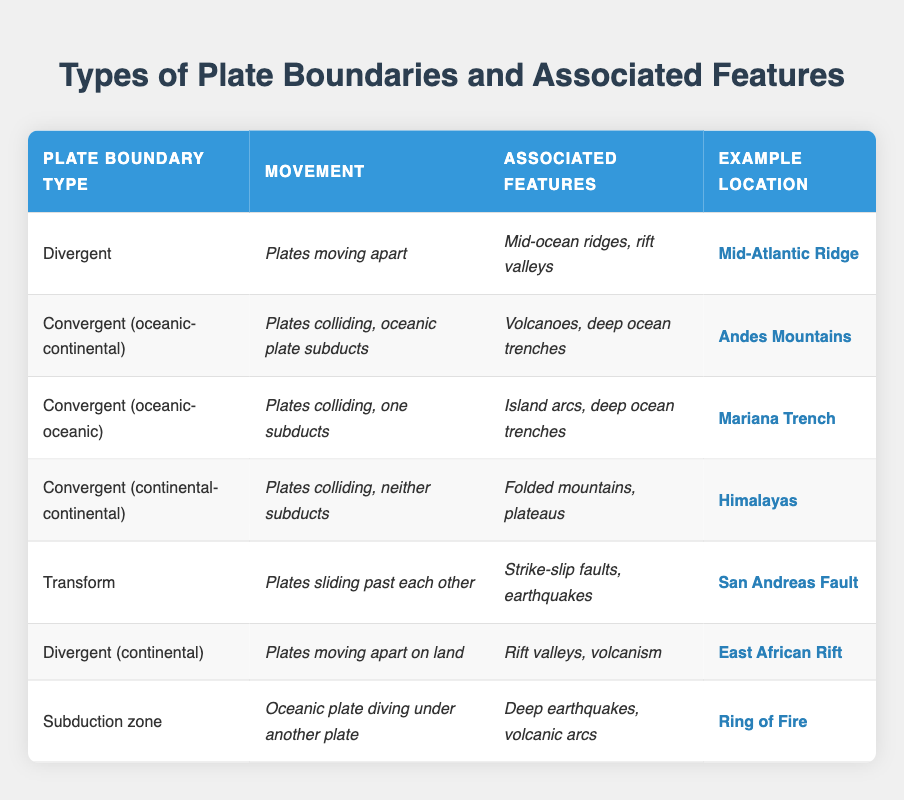What is the movement described for convergent (oceanic-continental) boundaries? According to the table, convergent (oceanic-continental) boundaries are characterized by plates colliding, and the oceanic plate subducts.
Answer: Plates colliding, oceanic plate subducts Which example location is associated with transform boundaries? Looking at the table, the location listed under transform boundaries is the San Andreas Fault.
Answer: San Andreas Fault Are rift valleys associated with divergent boundaries? Yes, based on the information in the table, rift valleys are indeed associated with divergent boundaries, indicated in the associated features column.
Answer: Yes What are the associated features of subduction zones? The table indicates that the associated features of subduction zones include deep earthquakes and volcanic arcs.
Answer: Deep earthquakes, volcanic arcs Which plate boundary type features island arcs and deep ocean trenches? The table specifies that the convergent (oceanic-oceanic) boundary type features island arcs and deep ocean trenches.
Answer: Convergent (oceanic-oceanic) Which movement type is related to the East African Rift? The East African Rift is listed under the divergent (continental) boundary type, which involves plates moving apart on land.
Answer: Plates moving apart on land What do the associated features of the Himalayas indicate about the type of boundary? The associated features of the Himalayas include folded mountains and plateaus, which are characteristic of convergent (continental-continental) boundaries.
Answer: Convergent (continental-continental) If you combine the associated features of divergent and transform boundaries, are there any common elements? Reviewing the table, the associated features for divergent boundaries include mid-ocean ridges and rift valleys, while transform boundaries feature strike-slip faults and earthquakes. Since these are distinct features, there are no common elements.
Answer: No 